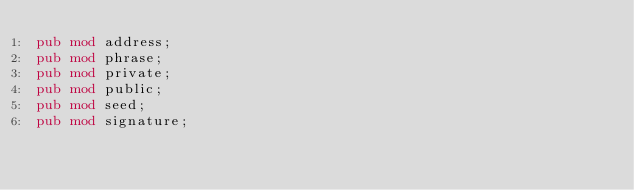Convert code to text. <code><loc_0><loc_0><loc_500><loc_500><_Rust_>pub mod address;
pub mod phrase;
pub mod private;
pub mod public;
pub mod seed;
pub mod signature;
</code> 